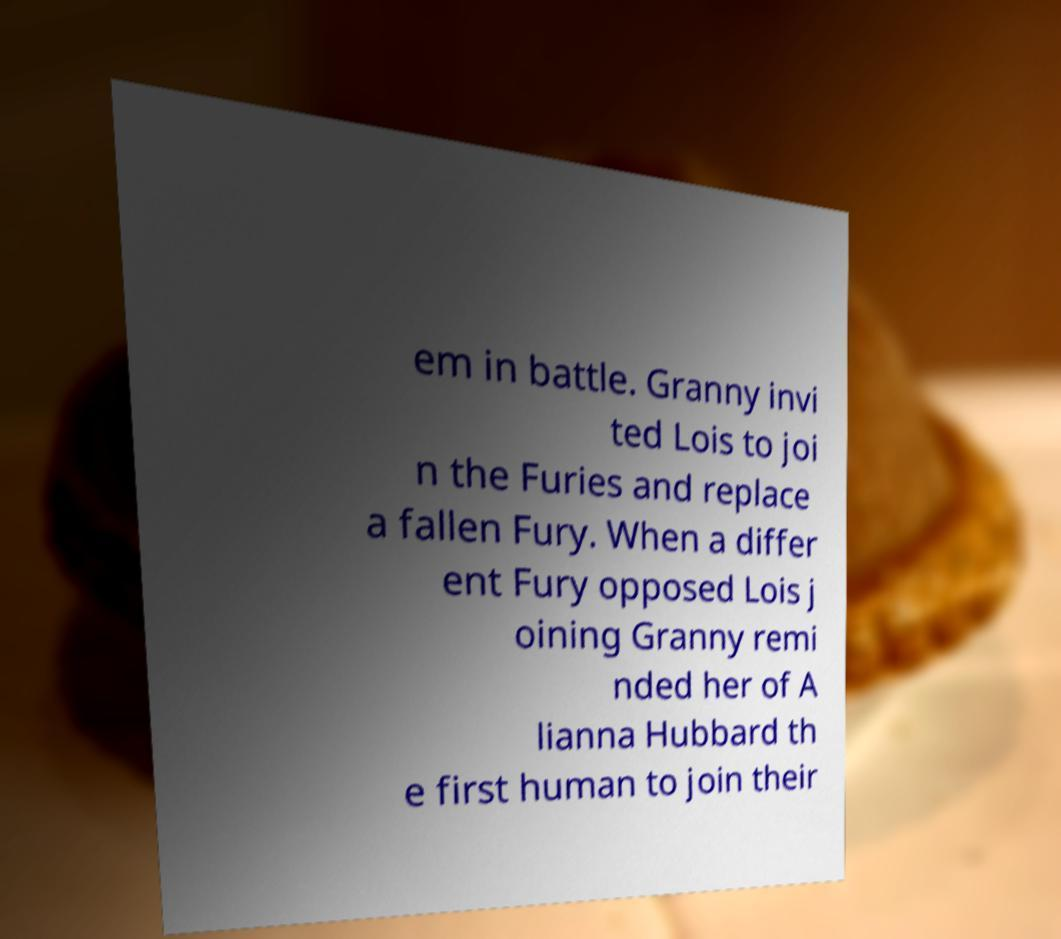Please identify and transcribe the text found in this image. em in battle. Granny invi ted Lois to joi n the Furies and replace a fallen Fury. When a differ ent Fury opposed Lois j oining Granny remi nded her of A lianna Hubbard th e first human to join their 